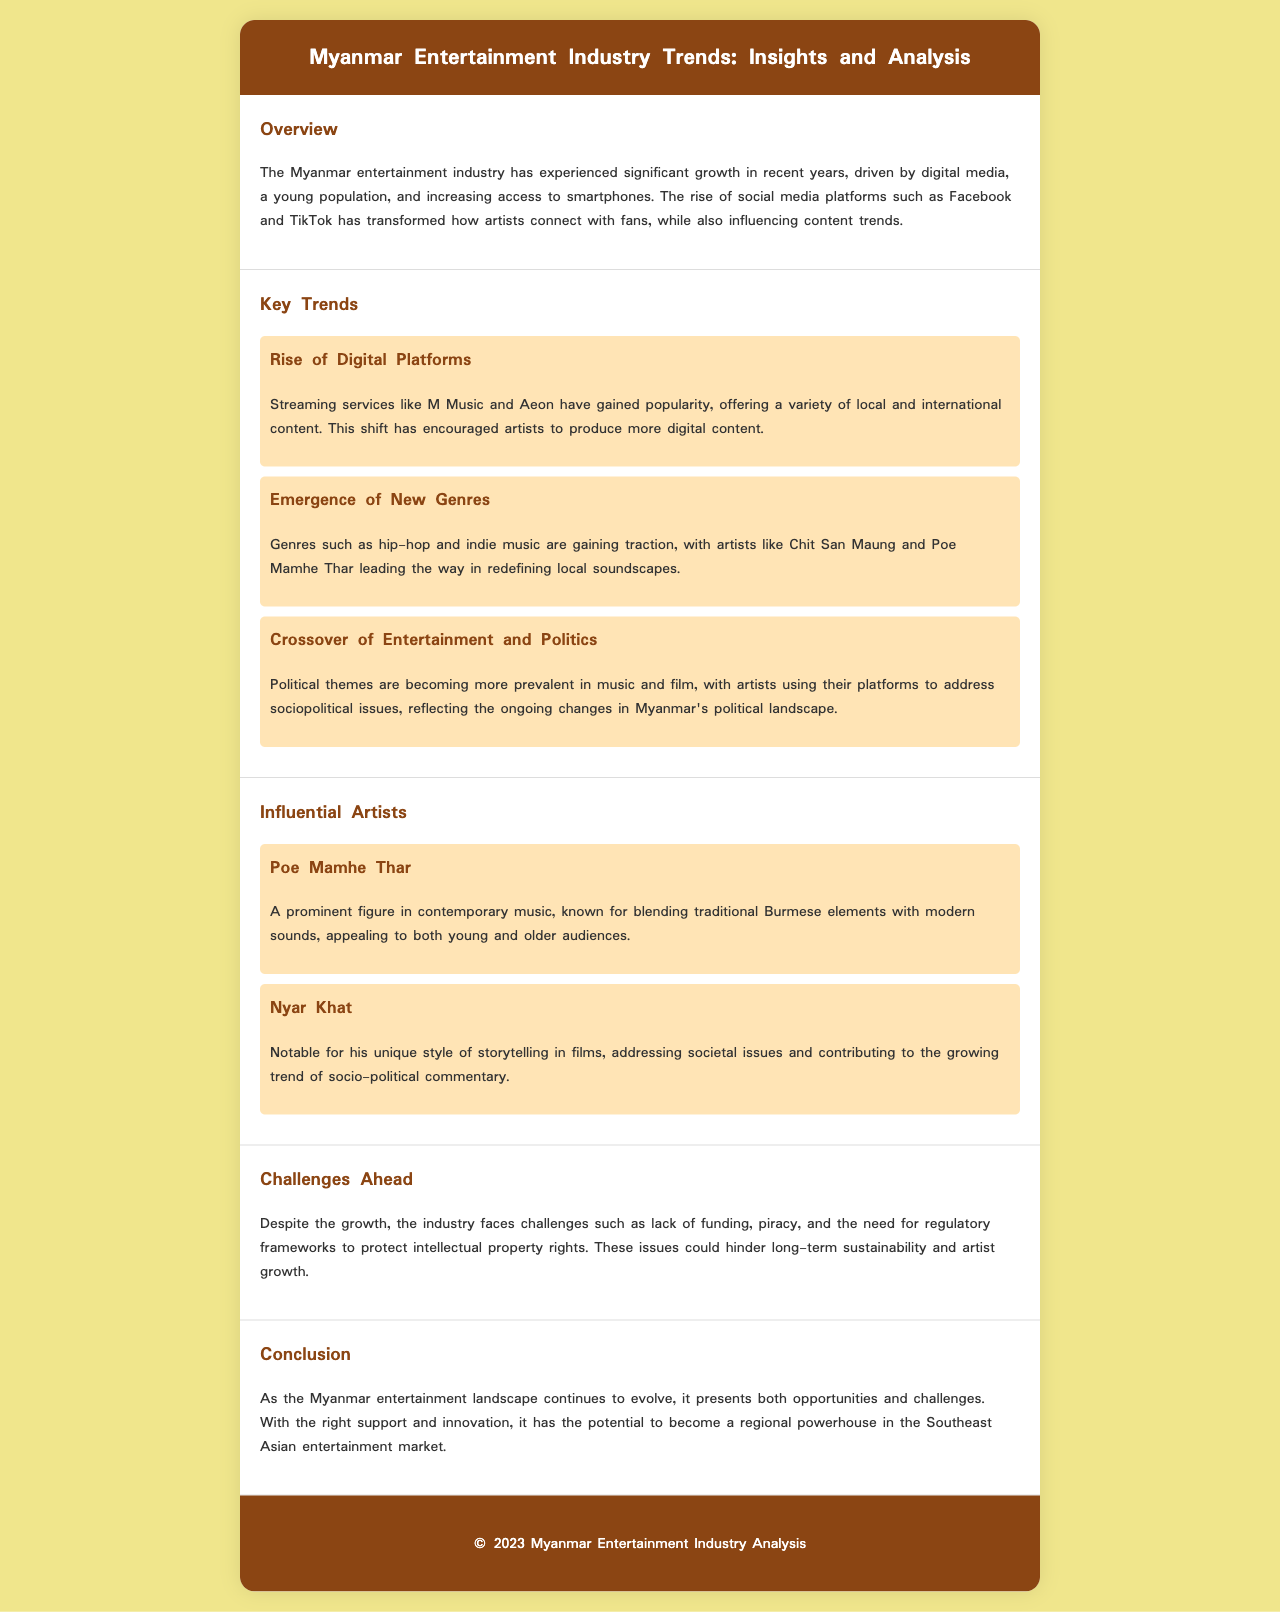What is the main factor driving the growth of the Myanmar entertainment industry? The document mentions that the significant growth is driven by digital media, a young population, and increasing access to smartphones.
Answer: Digital media Who are the artists mentioned as leading the emergence of new music genres? The document specifies Chit San Maung and Poe Mamhe Thar as artists redefining local soundscapes with new genres.
Answer: Chit San Maung and Poe Mamhe Thar What challenge does the Myanmar entertainment industry face? It states that one of the challenges is the lack of funding, among others, impacting long-term sustainability.
Answer: Lack of funding Which streaming service is mentioned as gaining popularity? The document specifically mentions M Music as a popular streaming service offering various content.
Answer: M Music What political theme is increasingly reflected in entertainment? The document discusses how political themes are becoming prevalent in music and film, addressing socio-political issues.
Answer: Socio-political issues Who is noted for storytelling in films? Nyar Khat is recognized for his unique storytelling style that addresses societal issues in films.
Answer: Nyar Khat What is the potential of the Myanmar entertainment industry according to the conclusion? The document concludes by stating its potential to become a regional powerhouse in the Southeast Asian entertainment market.
Answer: Regional powerhouse What is the document's year of analysis? The footer indicates the analysis is from the year 2023.
Answer: 2023 